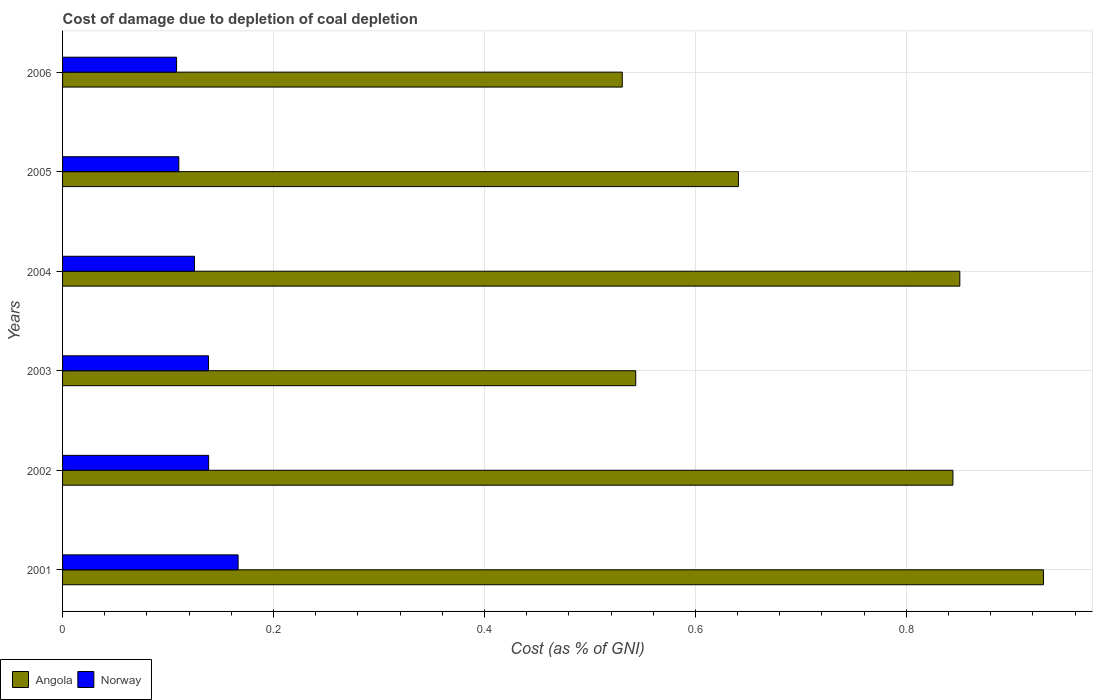How many groups of bars are there?
Your response must be concise. 6. Are the number of bars per tick equal to the number of legend labels?
Your answer should be compact. Yes. How many bars are there on the 6th tick from the top?
Your answer should be compact. 2. What is the cost of damage caused due to coal depletion in Norway in 2004?
Offer a terse response. 0.13. Across all years, what is the maximum cost of damage caused due to coal depletion in Angola?
Provide a short and direct response. 0.93. Across all years, what is the minimum cost of damage caused due to coal depletion in Angola?
Provide a short and direct response. 0.53. In which year was the cost of damage caused due to coal depletion in Angola maximum?
Provide a short and direct response. 2001. What is the total cost of damage caused due to coal depletion in Norway in the graph?
Offer a very short reply. 0.79. What is the difference between the cost of damage caused due to coal depletion in Angola in 2004 and that in 2006?
Offer a terse response. 0.32. What is the difference between the cost of damage caused due to coal depletion in Norway in 2003 and the cost of damage caused due to coal depletion in Angola in 2002?
Ensure brevity in your answer.  -0.71. What is the average cost of damage caused due to coal depletion in Norway per year?
Give a very brief answer. 0.13. In the year 2003, what is the difference between the cost of damage caused due to coal depletion in Norway and cost of damage caused due to coal depletion in Angola?
Provide a short and direct response. -0.41. In how many years, is the cost of damage caused due to coal depletion in Angola greater than 0.7600000000000001 %?
Provide a succinct answer. 3. What is the ratio of the cost of damage caused due to coal depletion in Norway in 2001 to that in 2005?
Provide a succinct answer. 1.51. Is the cost of damage caused due to coal depletion in Angola in 2001 less than that in 2005?
Ensure brevity in your answer.  No. What is the difference between the highest and the second highest cost of damage caused due to coal depletion in Angola?
Your response must be concise. 0.08. What is the difference between the highest and the lowest cost of damage caused due to coal depletion in Norway?
Keep it short and to the point. 0.06. What does the 2nd bar from the top in 2004 represents?
Ensure brevity in your answer.  Angola. What does the 1st bar from the bottom in 2003 represents?
Give a very brief answer. Angola. What is the difference between two consecutive major ticks on the X-axis?
Ensure brevity in your answer.  0.2. Does the graph contain any zero values?
Give a very brief answer. No. Does the graph contain grids?
Keep it short and to the point. Yes. How many legend labels are there?
Your answer should be compact. 2. What is the title of the graph?
Provide a short and direct response. Cost of damage due to depletion of coal depletion. What is the label or title of the X-axis?
Make the answer very short. Cost (as % of GNI). What is the Cost (as % of GNI) of Angola in 2001?
Your answer should be compact. 0.93. What is the Cost (as % of GNI) in Norway in 2001?
Provide a succinct answer. 0.17. What is the Cost (as % of GNI) of Angola in 2002?
Make the answer very short. 0.84. What is the Cost (as % of GNI) of Norway in 2002?
Offer a very short reply. 0.14. What is the Cost (as % of GNI) of Angola in 2003?
Provide a succinct answer. 0.54. What is the Cost (as % of GNI) in Norway in 2003?
Provide a succinct answer. 0.14. What is the Cost (as % of GNI) in Angola in 2004?
Give a very brief answer. 0.85. What is the Cost (as % of GNI) of Norway in 2004?
Your answer should be very brief. 0.13. What is the Cost (as % of GNI) of Angola in 2005?
Your response must be concise. 0.64. What is the Cost (as % of GNI) of Norway in 2005?
Give a very brief answer. 0.11. What is the Cost (as % of GNI) in Angola in 2006?
Keep it short and to the point. 0.53. What is the Cost (as % of GNI) of Norway in 2006?
Offer a very short reply. 0.11. Across all years, what is the maximum Cost (as % of GNI) in Angola?
Your answer should be very brief. 0.93. Across all years, what is the maximum Cost (as % of GNI) of Norway?
Your answer should be very brief. 0.17. Across all years, what is the minimum Cost (as % of GNI) of Angola?
Give a very brief answer. 0.53. Across all years, what is the minimum Cost (as % of GNI) of Norway?
Provide a short and direct response. 0.11. What is the total Cost (as % of GNI) of Angola in the graph?
Your response must be concise. 4.34. What is the total Cost (as % of GNI) in Norway in the graph?
Provide a succinct answer. 0.79. What is the difference between the Cost (as % of GNI) in Angola in 2001 and that in 2002?
Your response must be concise. 0.09. What is the difference between the Cost (as % of GNI) in Norway in 2001 and that in 2002?
Provide a succinct answer. 0.03. What is the difference between the Cost (as % of GNI) in Angola in 2001 and that in 2003?
Your answer should be compact. 0.39. What is the difference between the Cost (as % of GNI) of Norway in 2001 and that in 2003?
Your answer should be compact. 0.03. What is the difference between the Cost (as % of GNI) of Angola in 2001 and that in 2004?
Offer a very short reply. 0.08. What is the difference between the Cost (as % of GNI) in Norway in 2001 and that in 2004?
Offer a terse response. 0.04. What is the difference between the Cost (as % of GNI) of Angola in 2001 and that in 2005?
Ensure brevity in your answer.  0.29. What is the difference between the Cost (as % of GNI) of Norway in 2001 and that in 2005?
Make the answer very short. 0.06. What is the difference between the Cost (as % of GNI) of Angola in 2001 and that in 2006?
Your answer should be compact. 0.4. What is the difference between the Cost (as % of GNI) in Norway in 2001 and that in 2006?
Ensure brevity in your answer.  0.06. What is the difference between the Cost (as % of GNI) in Angola in 2002 and that in 2003?
Your answer should be very brief. 0.3. What is the difference between the Cost (as % of GNI) in Angola in 2002 and that in 2004?
Your answer should be compact. -0.01. What is the difference between the Cost (as % of GNI) of Norway in 2002 and that in 2004?
Offer a terse response. 0.01. What is the difference between the Cost (as % of GNI) in Angola in 2002 and that in 2005?
Make the answer very short. 0.2. What is the difference between the Cost (as % of GNI) in Norway in 2002 and that in 2005?
Offer a very short reply. 0.03. What is the difference between the Cost (as % of GNI) of Angola in 2002 and that in 2006?
Offer a very short reply. 0.31. What is the difference between the Cost (as % of GNI) in Norway in 2002 and that in 2006?
Ensure brevity in your answer.  0.03. What is the difference between the Cost (as % of GNI) in Angola in 2003 and that in 2004?
Keep it short and to the point. -0.31. What is the difference between the Cost (as % of GNI) in Norway in 2003 and that in 2004?
Keep it short and to the point. 0.01. What is the difference between the Cost (as % of GNI) in Angola in 2003 and that in 2005?
Your answer should be compact. -0.1. What is the difference between the Cost (as % of GNI) of Norway in 2003 and that in 2005?
Make the answer very short. 0.03. What is the difference between the Cost (as % of GNI) of Angola in 2003 and that in 2006?
Offer a terse response. 0.01. What is the difference between the Cost (as % of GNI) in Norway in 2003 and that in 2006?
Provide a succinct answer. 0.03. What is the difference between the Cost (as % of GNI) of Angola in 2004 and that in 2005?
Provide a succinct answer. 0.21. What is the difference between the Cost (as % of GNI) in Norway in 2004 and that in 2005?
Your answer should be compact. 0.01. What is the difference between the Cost (as % of GNI) in Angola in 2004 and that in 2006?
Offer a terse response. 0.32. What is the difference between the Cost (as % of GNI) in Norway in 2004 and that in 2006?
Give a very brief answer. 0.02. What is the difference between the Cost (as % of GNI) in Angola in 2005 and that in 2006?
Offer a terse response. 0.11. What is the difference between the Cost (as % of GNI) in Norway in 2005 and that in 2006?
Your answer should be compact. 0. What is the difference between the Cost (as % of GNI) of Angola in 2001 and the Cost (as % of GNI) of Norway in 2002?
Provide a succinct answer. 0.79. What is the difference between the Cost (as % of GNI) in Angola in 2001 and the Cost (as % of GNI) in Norway in 2003?
Your answer should be very brief. 0.79. What is the difference between the Cost (as % of GNI) in Angola in 2001 and the Cost (as % of GNI) in Norway in 2004?
Your answer should be very brief. 0.81. What is the difference between the Cost (as % of GNI) in Angola in 2001 and the Cost (as % of GNI) in Norway in 2005?
Provide a short and direct response. 0.82. What is the difference between the Cost (as % of GNI) of Angola in 2001 and the Cost (as % of GNI) of Norway in 2006?
Provide a succinct answer. 0.82. What is the difference between the Cost (as % of GNI) in Angola in 2002 and the Cost (as % of GNI) in Norway in 2003?
Provide a short and direct response. 0.71. What is the difference between the Cost (as % of GNI) in Angola in 2002 and the Cost (as % of GNI) in Norway in 2004?
Provide a short and direct response. 0.72. What is the difference between the Cost (as % of GNI) in Angola in 2002 and the Cost (as % of GNI) in Norway in 2005?
Offer a very short reply. 0.73. What is the difference between the Cost (as % of GNI) of Angola in 2002 and the Cost (as % of GNI) of Norway in 2006?
Make the answer very short. 0.74. What is the difference between the Cost (as % of GNI) in Angola in 2003 and the Cost (as % of GNI) in Norway in 2004?
Offer a very short reply. 0.42. What is the difference between the Cost (as % of GNI) of Angola in 2003 and the Cost (as % of GNI) of Norway in 2005?
Offer a very short reply. 0.43. What is the difference between the Cost (as % of GNI) in Angola in 2003 and the Cost (as % of GNI) in Norway in 2006?
Give a very brief answer. 0.44. What is the difference between the Cost (as % of GNI) in Angola in 2004 and the Cost (as % of GNI) in Norway in 2005?
Your answer should be very brief. 0.74. What is the difference between the Cost (as % of GNI) in Angola in 2004 and the Cost (as % of GNI) in Norway in 2006?
Give a very brief answer. 0.74. What is the difference between the Cost (as % of GNI) in Angola in 2005 and the Cost (as % of GNI) in Norway in 2006?
Your answer should be very brief. 0.53. What is the average Cost (as % of GNI) of Angola per year?
Your answer should be compact. 0.72. What is the average Cost (as % of GNI) in Norway per year?
Ensure brevity in your answer.  0.13. In the year 2001, what is the difference between the Cost (as % of GNI) in Angola and Cost (as % of GNI) in Norway?
Keep it short and to the point. 0.76. In the year 2002, what is the difference between the Cost (as % of GNI) in Angola and Cost (as % of GNI) in Norway?
Provide a succinct answer. 0.71. In the year 2003, what is the difference between the Cost (as % of GNI) of Angola and Cost (as % of GNI) of Norway?
Make the answer very short. 0.41. In the year 2004, what is the difference between the Cost (as % of GNI) of Angola and Cost (as % of GNI) of Norway?
Make the answer very short. 0.73. In the year 2005, what is the difference between the Cost (as % of GNI) in Angola and Cost (as % of GNI) in Norway?
Give a very brief answer. 0.53. In the year 2006, what is the difference between the Cost (as % of GNI) in Angola and Cost (as % of GNI) in Norway?
Give a very brief answer. 0.42. What is the ratio of the Cost (as % of GNI) in Angola in 2001 to that in 2002?
Your response must be concise. 1.1. What is the ratio of the Cost (as % of GNI) in Norway in 2001 to that in 2002?
Offer a terse response. 1.2. What is the ratio of the Cost (as % of GNI) of Angola in 2001 to that in 2003?
Keep it short and to the point. 1.71. What is the ratio of the Cost (as % of GNI) of Norway in 2001 to that in 2003?
Offer a very short reply. 1.2. What is the ratio of the Cost (as % of GNI) of Angola in 2001 to that in 2004?
Make the answer very short. 1.09. What is the ratio of the Cost (as % of GNI) of Norway in 2001 to that in 2004?
Your answer should be very brief. 1.33. What is the ratio of the Cost (as % of GNI) in Angola in 2001 to that in 2005?
Your answer should be compact. 1.45. What is the ratio of the Cost (as % of GNI) of Norway in 2001 to that in 2005?
Your answer should be compact. 1.51. What is the ratio of the Cost (as % of GNI) in Angola in 2001 to that in 2006?
Your answer should be compact. 1.75. What is the ratio of the Cost (as % of GNI) of Norway in 2001 to that in 2006?
Give a very brief answer. 1.54. What is the ratio of the Cost (as % of GNI) in Angola in 2002 to that in 2003?
Offer a very short reply. 1.55. What is the ratio of the Cost (as % of GNI) in Angola in 2002 to that in 2004?
Your answer should be compact. 0.99. What is the ratio of the Cost (as % of GNI) of Norway in 2002 to that in 2004?
Ensure brevity in your answer.  1.11. What is the ratio of the Cost (as % of GNI) in Angola in 2002 to that in 2005?
Give a very brief answer. 1.32. What is the ratio of the Cost (as % of GNI) in Norway in 2002 to that in 2005?
Provide a short and direct response. 1.26. What is the ratio of the Cost (as % of GNI) of Angola in 2002 to that in 2006?
Provide a short and direct response. 1.59. What is the ratio of the Cost (as % of GNI) of Norway in 2002 to that in 2006?
Provide a succinct answer. 1.28. What is the ratio of the Cost (as % of GNI) in Angola in 2003 to that in 2004?
Ensure brevity in your answer.  0.64. What is the ratio of the Cost (as % of GNI) of Norway in 2003 to that in 2004?
Provide a short and direct response. 1.11. What is the ratio of the Cost (as % of GNI) of Angola in 2003 to that in 2005?
Make the answer very short. 0.85. What is the ratio of the Cost (as % of GNI) of Norway in 2003 to that in 2005?
Provide a short and direct response. 1.26. What is the ratio of the Cost (as % of GNI) of Angola in 2003 to that in 2006?
Keep it short and to the point. 1.02. What is the ratio of the Cost (as % of GNI) of Norway in 2003 to that in 2006?
Your answer should be very brief. 1.28. What is the ratio of the Cost (as % of GNI) of Angola in 2004 to that in 2005?
Ensure brevity in your answer.  1.33. What is the ratio of the Cost (as % of GNI) in Norway in 2004 to that in 2005?
Offer a terse response. 1.13. What is the ratio of the Cost (as % of GNI) of Angola in 2004 to that in 2006?
Offer a terse response. 1.6. What is the ratio of the Cost (as % of GNI) in Norway in 2004 to that in 2006?
Your response must be concise. 1.16. What is the ratio of the Cost (as % of GNI) of Angola in 2005 to that in 2006?
Provide a short and direct response. 1.21. What is the ratio of the Cost (as % of GNI) in Norway in 2005 to that in 2006?
Your answer should be very brief. 1.02. What is the difference between the highest and the second highest Cost (as % of GNI) of Angola?
Give a very brief answer. 0.08. What is the difference between the highest and the second highest Cost (as % of GNI) of Norway?
Your answer should be very brief. 0.03. What is the difference between the highest and the lowest Cost (as % of GNI) of Angola?
Your answer should be compact. 0.4. What is the difference between the highest and the lowest Cost (as % of GNI) of Norway?
Offer a very short reply. 0.06. 